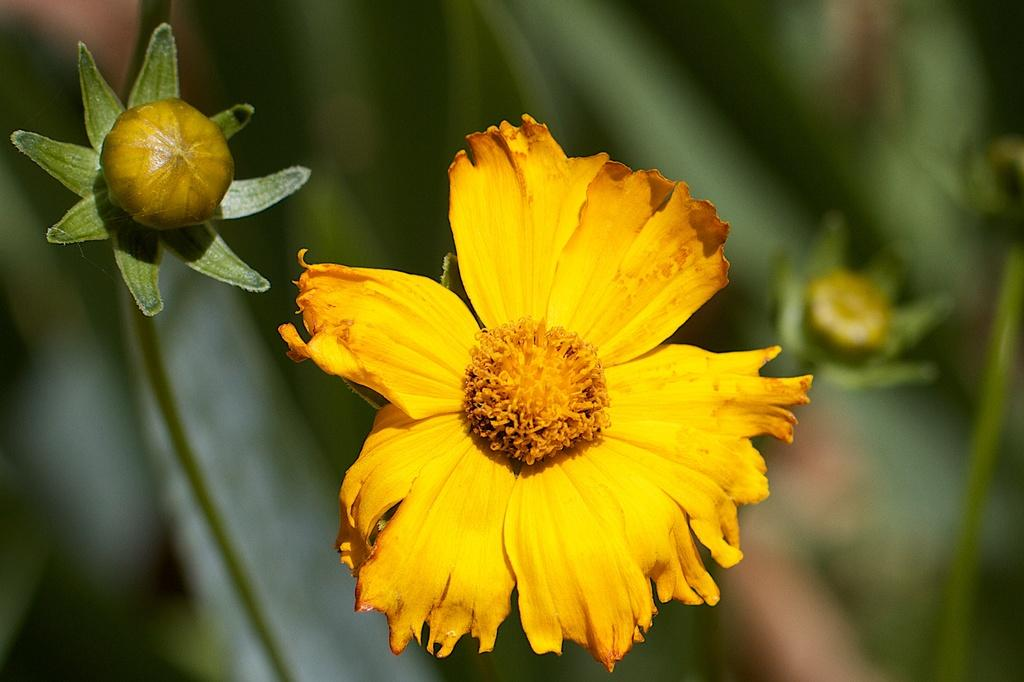What type of flower can be seen in the image? There is a yellow flower in the image. Are there any unopened flowers in the image? Yes, there are flower buds in the image. Can you describe the background of the image? The background of the image is blurred. What type of wool can be seen on the desk in the image? There is no wool or desk present in the image; it features a yellow flower and flower buds with a blurred background. 